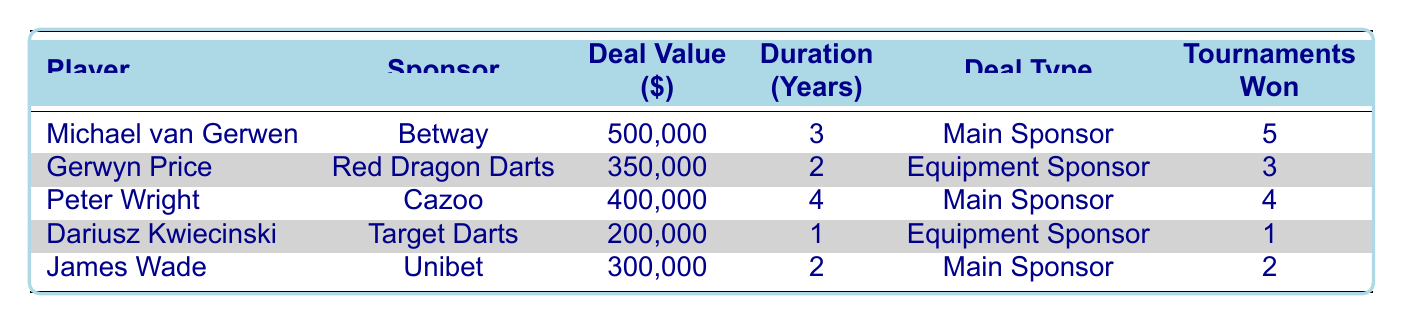What is the total deal value for all players combined? To find the total deal value, we add the deal values for each player: 500000 (Michael van Gerwen) + 350000 (Gerwyn Price) + 400000 (Peter Wright) + 200000 (Dariusz Kwiecinski) + 300000 (James Wade) = 1850000.
Answer: 1850000 How many tournaments did Peter Wright win? From the table, it shows that Peter Wright won 4 tournaments according to his performance metrics.
Answer: 4 Is the deal value of Gerwyn Price less than that of James Wade? Gerwyn Price's deal value is 350000 and James Wade's is 300000. Since 350000 is greater than 300000, the statement is false.
Answer: No What is the average duration of the sponsorship deals? The durations are: 3 (Michael van Gerwen) + 2 (Gerwyn Price) + 4 (Peter Wright) + 1 (Dariusz Kwiecinski) + 2 (James Wade) = 12 years and there are 5 players, so the average is 12/5 = 2.4 years.
Answer: 2.4 years Who has the highest number of tournaments won? Looking at the tournaments won, Michael van Gerwen has the highest at 5, followed by Peter Wright with 4, and others with fewer. Therefore, Michael van Gerwen has the most tournaments won.
Answer: Michael van Gerwen 